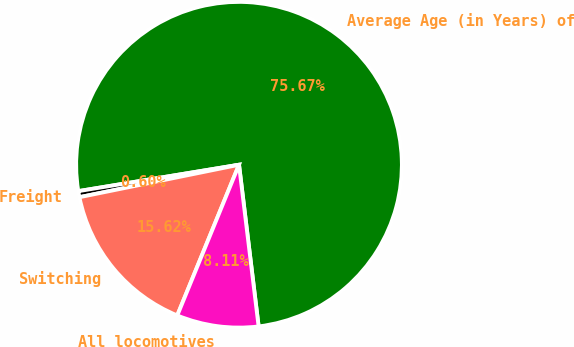Convert chart to OTSL. <chart><loc_0><loc_0><loc_500><loc_500><pie_chart><fcel>Average Age (in Years) of<fcel>Freight<fcel>Switching<fcel>All locomotives<nl><fcel>75.67%<fcel>0.6%<fcel>15.62%<fcel>8.11%<nl></chart> 